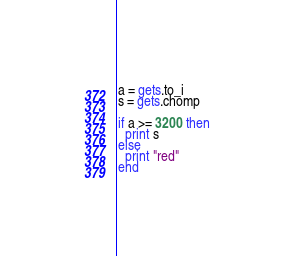Convert code to text. <code><loc_0><loc_0><loc_500><loc_500><_Ruby_>a = gets.to_i
s = gets.chomp

if a >= 3200 then
  print s
else
  print "red"
end</code> 